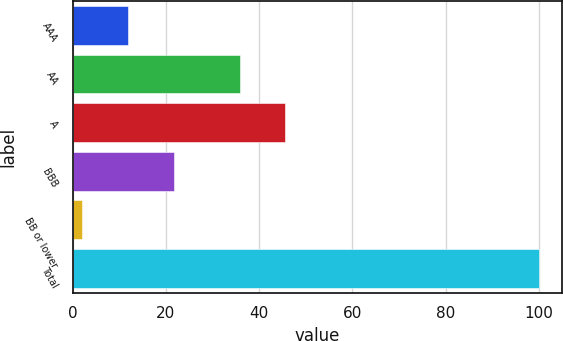Convert chart to OTSL. <chart><loc_0><loc_0><loc_500><loc_500><bar_chart><fcel>AAA<fcel>AA<fcel>A<fcel>BBB<fcel>BB or lower<fcel>Total<nl><fcel>11.89<fcel>35.8<fcel>45.59<fcel>21.68<fcel>2.1<fcel>100<nl></chart> 